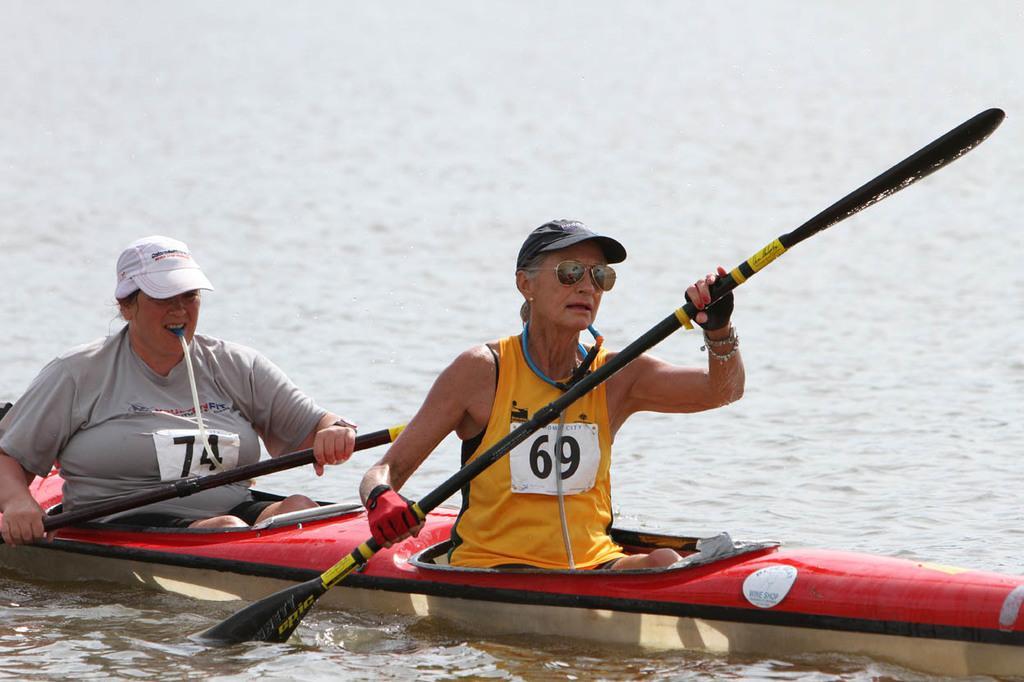Please provide a concise description of this image. In this image, I can see two persons holding paddles and sitting in a kayak boat, which is on the water. 